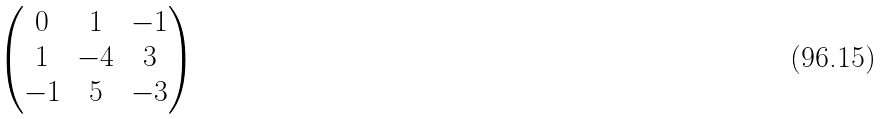<formula> <loc_0><loc_0><loc_500><loc_500>\begin{pmatrix} 0 & 1 & - 1 \\ 1 & - 4 & 3 \\ - 1 & 5 & - 3 \end{pmatrix}</formula> 